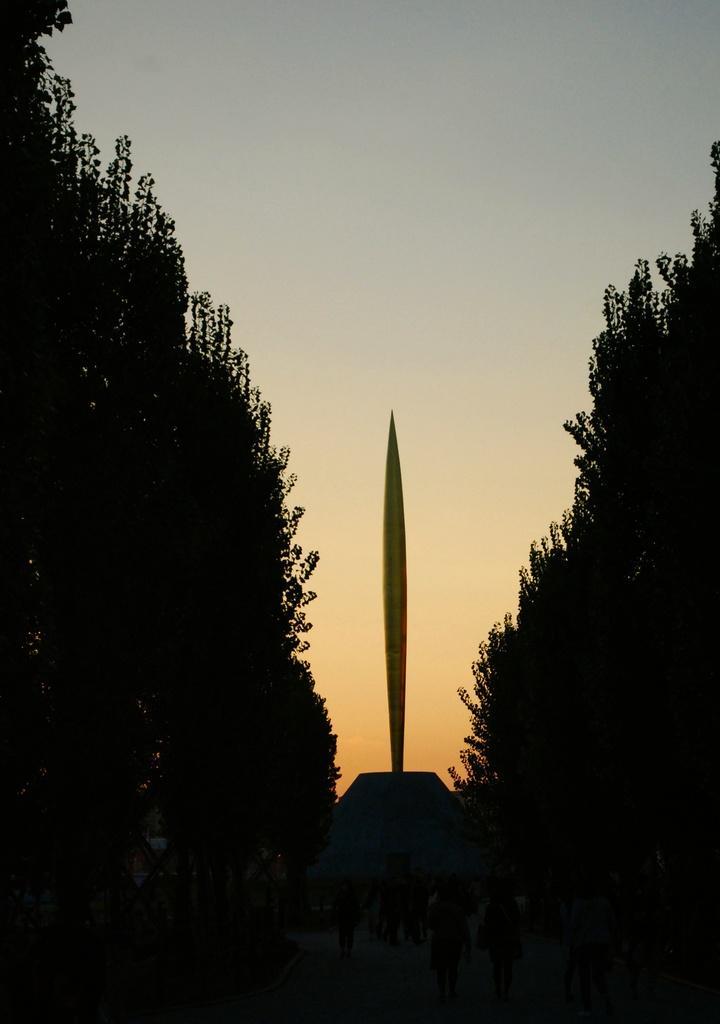Can you describe this image briefly? In this image I can see trees, background I can see a pole, and sky in white and blue color. 